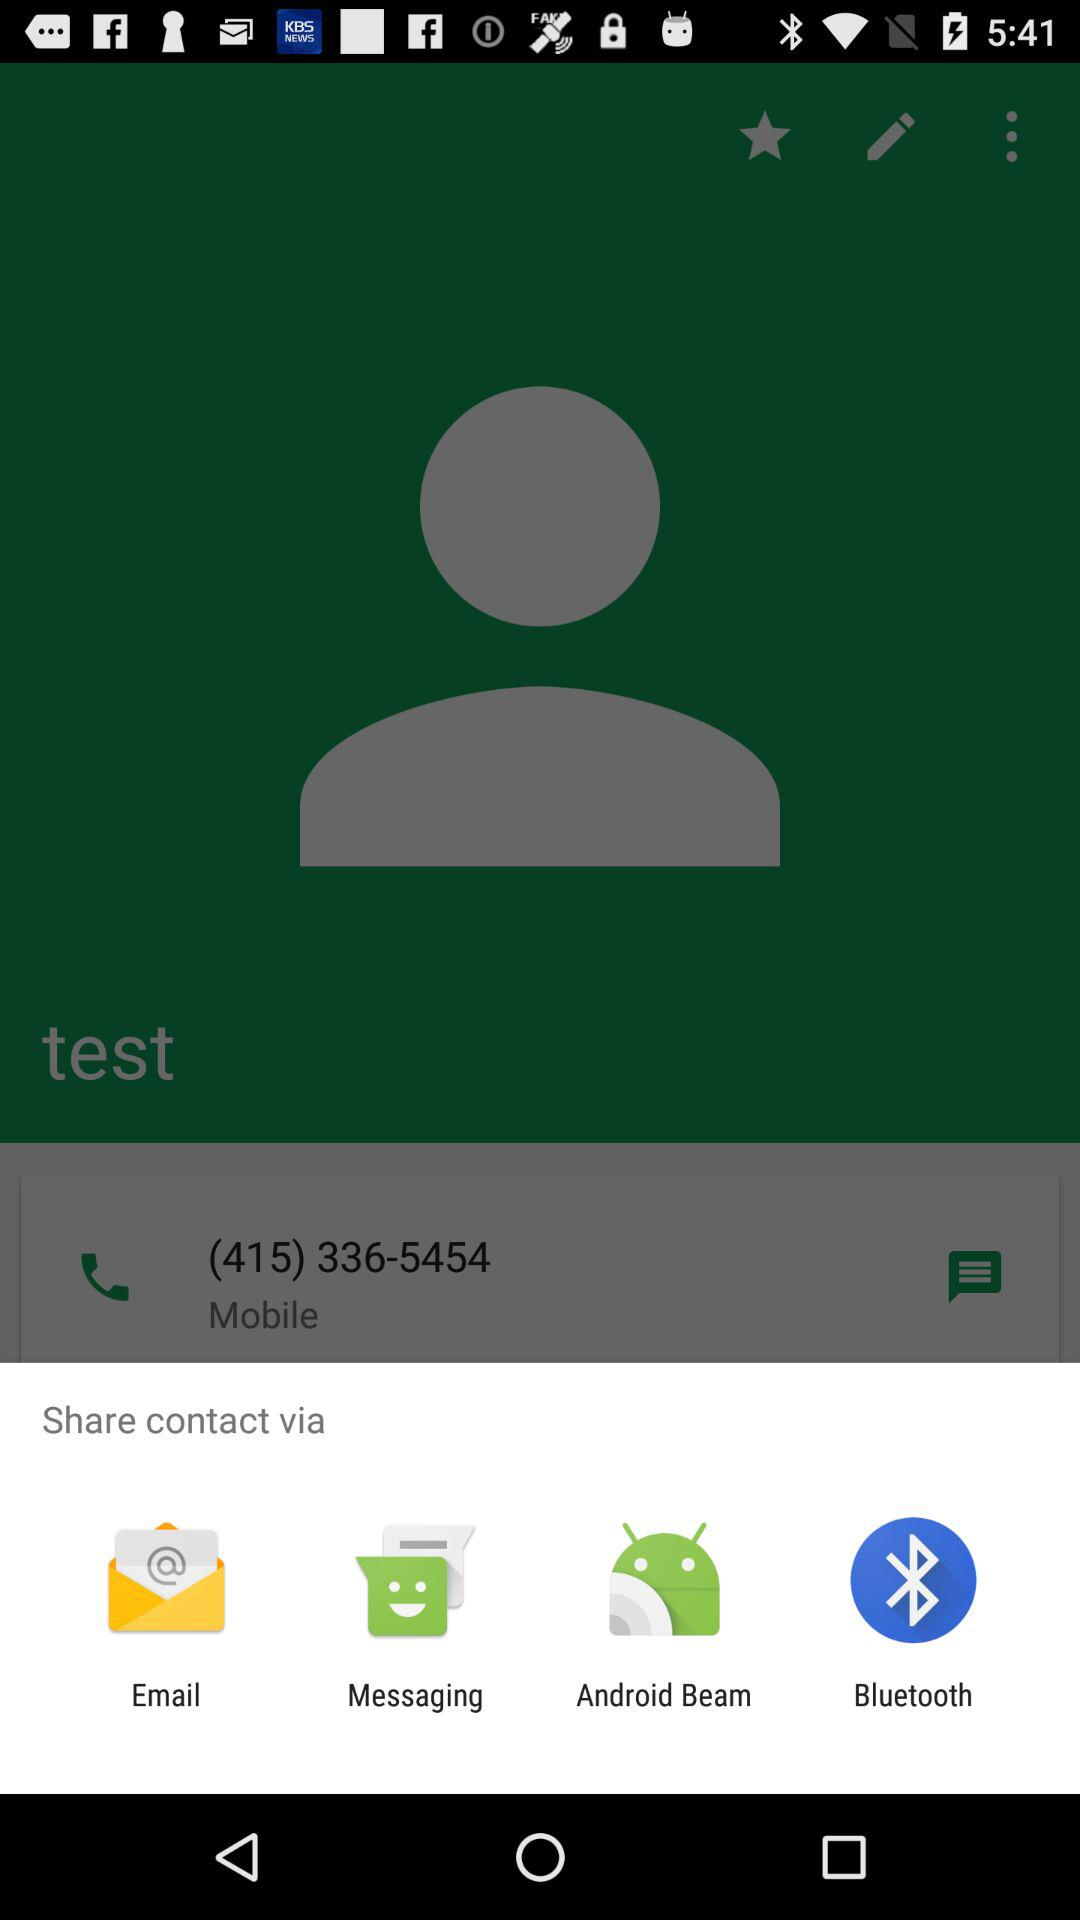By which applications can be share the contact? You can share the contact "Email", "Messaging", "Android Beam" and "Bluetooth". 